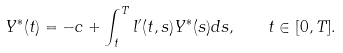<formula> <loc_0><loc_0><loc_500><loc_500>Y ^ { * } ( t ) = - c + \int _ { t } ^ { T } l ^ { \prime } ( t , s ) Y ^ { * } ( s ) d s , \quad t \in [ 0 , T ] .</formula> 